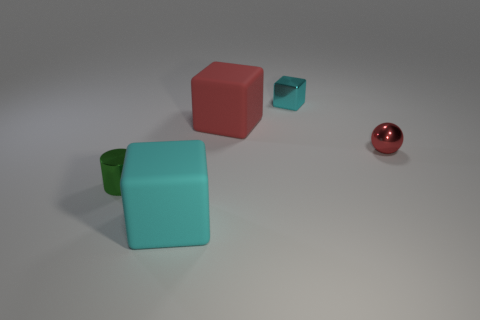What size is the rubber thing that is the same color as the small metallic block?
Make the answer very short. Large. There is a small green metal thing left of the large block that is right of the large rubber block that is in front of the cylinder; what shape is it?
Ensure brevity in your answer.  Cylinder. The object that is right of the large red rubber block and in front of the red block is made of what material?
Keep it short and to the point. Metal. There is a large matte block that is behind the cyan block that is in front of the big red matte object behind the tiny green metal cylinder; what is its color?
Your answer should be compact. Red. What number of brown objects are either small metal cylinders or large matte cylinders?
Offer a very short reply. 0. What number of other objects are there of the same size as the red matte thing?
Your answer should be very brief. 1. What number of cyan matte cubes are there?
Your answer should be compact. 1. Are there any other things that are the same shape as the red matte object?
Your answer should be very brief. Yes. Do the large object that is in front of the small green metal object and the block behind the red rubber block have the same material?
Provide a succinct answer. No. What is the material of the small cyan cube?
Make the answer very short. Metal. 